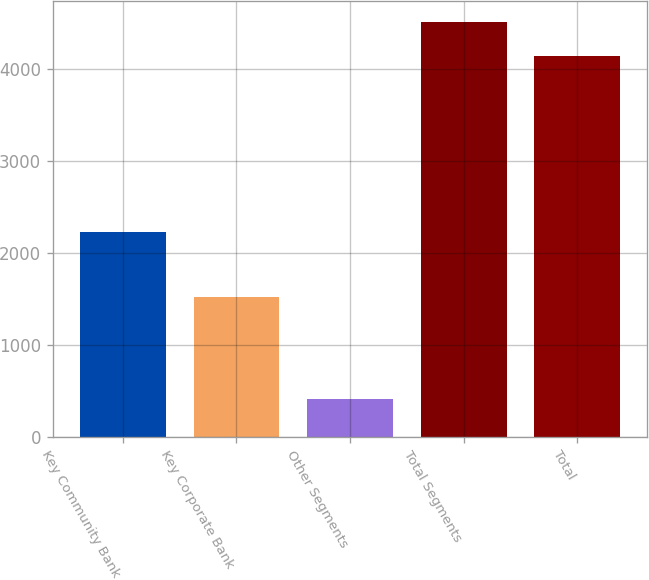<chart> <loc_0><loc_0><loc_500><loc_500><bar_chart><fcel>Key Community Bank<fcel>Key Corporate Bank<fcel>Other Segments<fcel>Total Segments<fcel>Total<nl><fcel>2225<fcel>1521<fcel>414<fcel>4518.6<fcel>4144<nl></chart> 